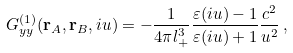<formula> <loc_0><loc_0><loc_500><loc_500>G ^ { ( 1 ) } _ { y y } ( \mathbf r _ { A } , \mathbf r _ { B } , i u ) = - \frac { 1 } { 4 \pi l _ { + } ^ { 3 } } \frac { \varepsilon ( i u ) - 1 } { \varepsilon ( i u ) + 1 } \frac { c ^ { 2 } } { u ^ { 2 } } \, ,</formula> 